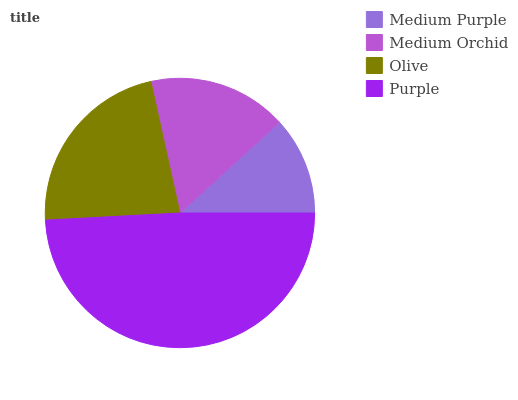Is Medium Purple the minimum?
Answer yes or no. Yes. Is Purple the maximum?
Answer yes or no. Yes. Is Medium Orchid the minimum?
Answer yes or no. No. Is Medium Orchid the maximum?
Answer yes or no. No. Is Medium Orchid greater than Medium Purple?
Answer yes or no. Yes. Is Medium Purple less than Medium Orchid?
Answer yes or no. Yes. Is Medium Purple greater than Medium Orchid?
Answer yes or no. No. Is Medium Orchid less than Medium Purple?
Answer yes or no. No. Is Olive the high median?
Answer yes or no. Yes. Is Medium Orchid the low median?
Answer yes or no. Yes. Is Medium Purple the high median?
Answer yes or no. No. Is Olive the low median?
Answer yes or no. No. 